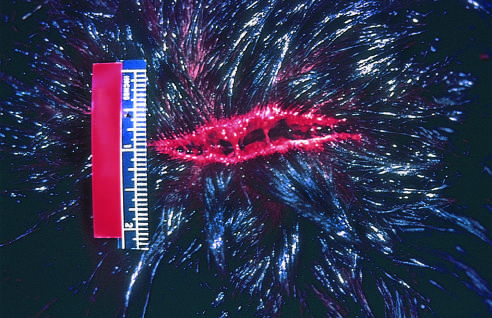re a few interspersed neutrophils, much smaller in size and with compact, lobate nuclei, evident?
Answer the question using a single word or phrase. No 